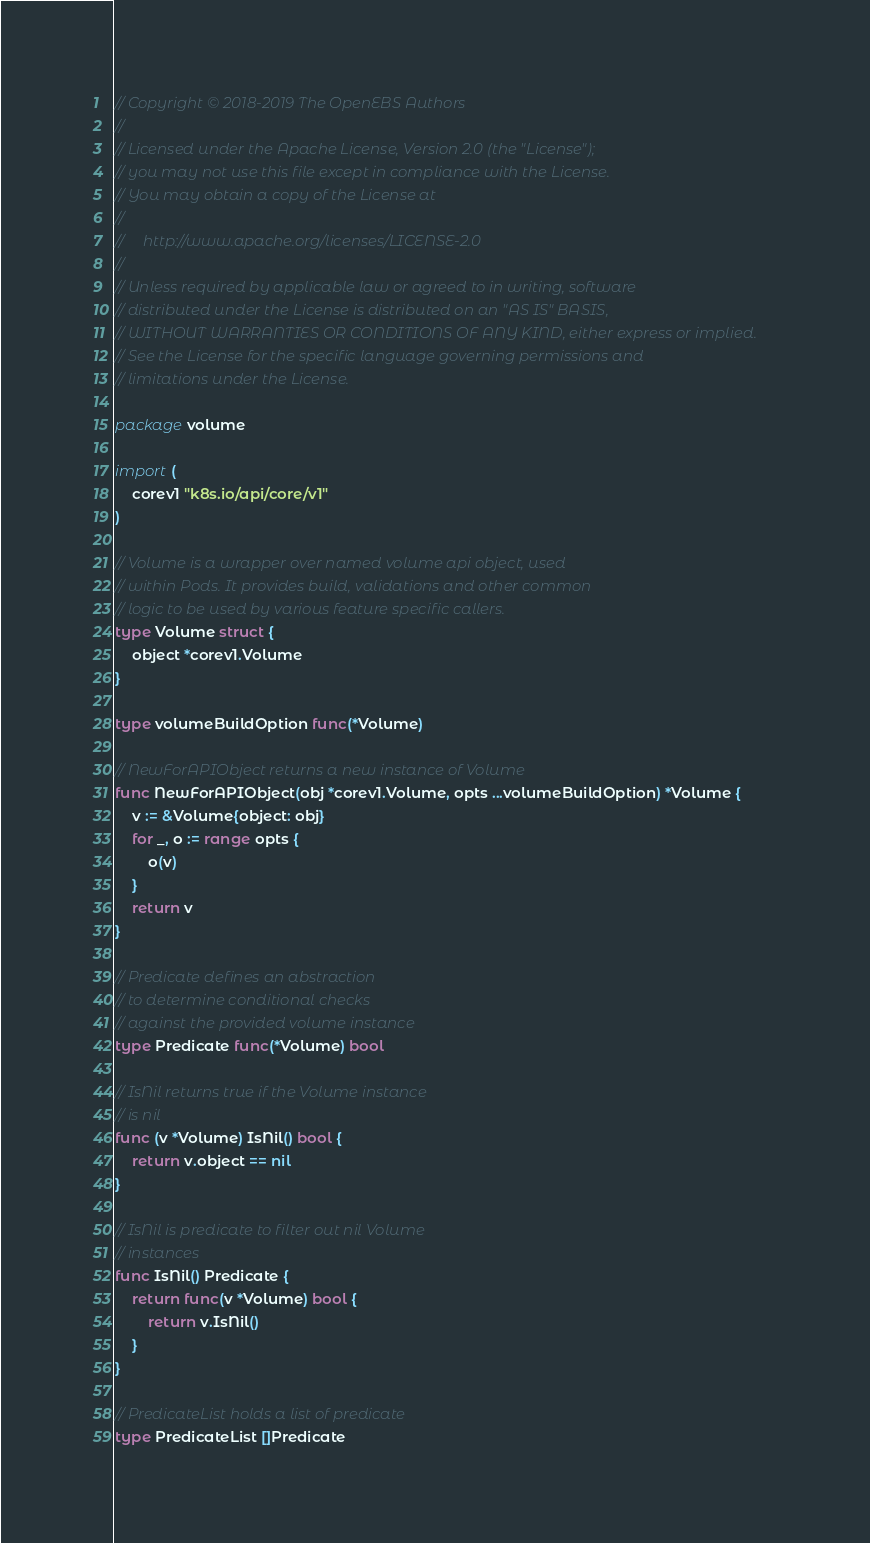<code> <loc_0><loc_0><loc_500><loc_500><_Go_>// Copyright © 2018-2019 The OpenEBS Authors
//
// Licensed under the Apache License, Version 2.0 (the "License");
// you may not use this file except in compliance with the License.
// You may obtain a copy of the License at
//
//     http://www.apache.org/licenses/LICENSE-2.0
//
// Unless required by applicable law or agreed to in writing, software
// distributed under the License is distributed on an "AS IS" BASIS,
// WITHOUT WARRANTIES OR CONDITIONS OF ANY KIND, either express or implied.
// See the License for the specific language governing permissions and
// limitations under the License.

package volume

import (
	corev1 "k8s.io/api/core/v1"
)

// Volume is a wrapper over named volume api object, used
// within Pods. It provides build, validations and other common
// logic to be used by various feature specific callers.
type Volume struct {
	object *corev1.Volume
}

type volumeBuildOption func(*Volume)

// NewForAPIObject returns a new instance of Volume
func NewForAPIObject(obj *corev1.Volume, opts ...volumeBuildOption) *Volume {
	v := &Volume{object: obj}
	for _, o := range opts {
		o(v)
	}
	return v
}

// Predicate defines an abstraction
// to determine conditional checks
// against the provided volume instance
type Predicate func(*Volume) bool

// IsNil returns true if the Volume instance
// is nil
func (v *Volume) IsNil() bool {
	return v.object == nil
}

// IsNil is predicate to filter out nil Volume
// instances
func IsNil() Predicate {
	return func(v *Volume) bool {
		return v.IsNil()
	}
}

// PredicateList holds a list of predicate
type PredicateList []Predicate
</code> 